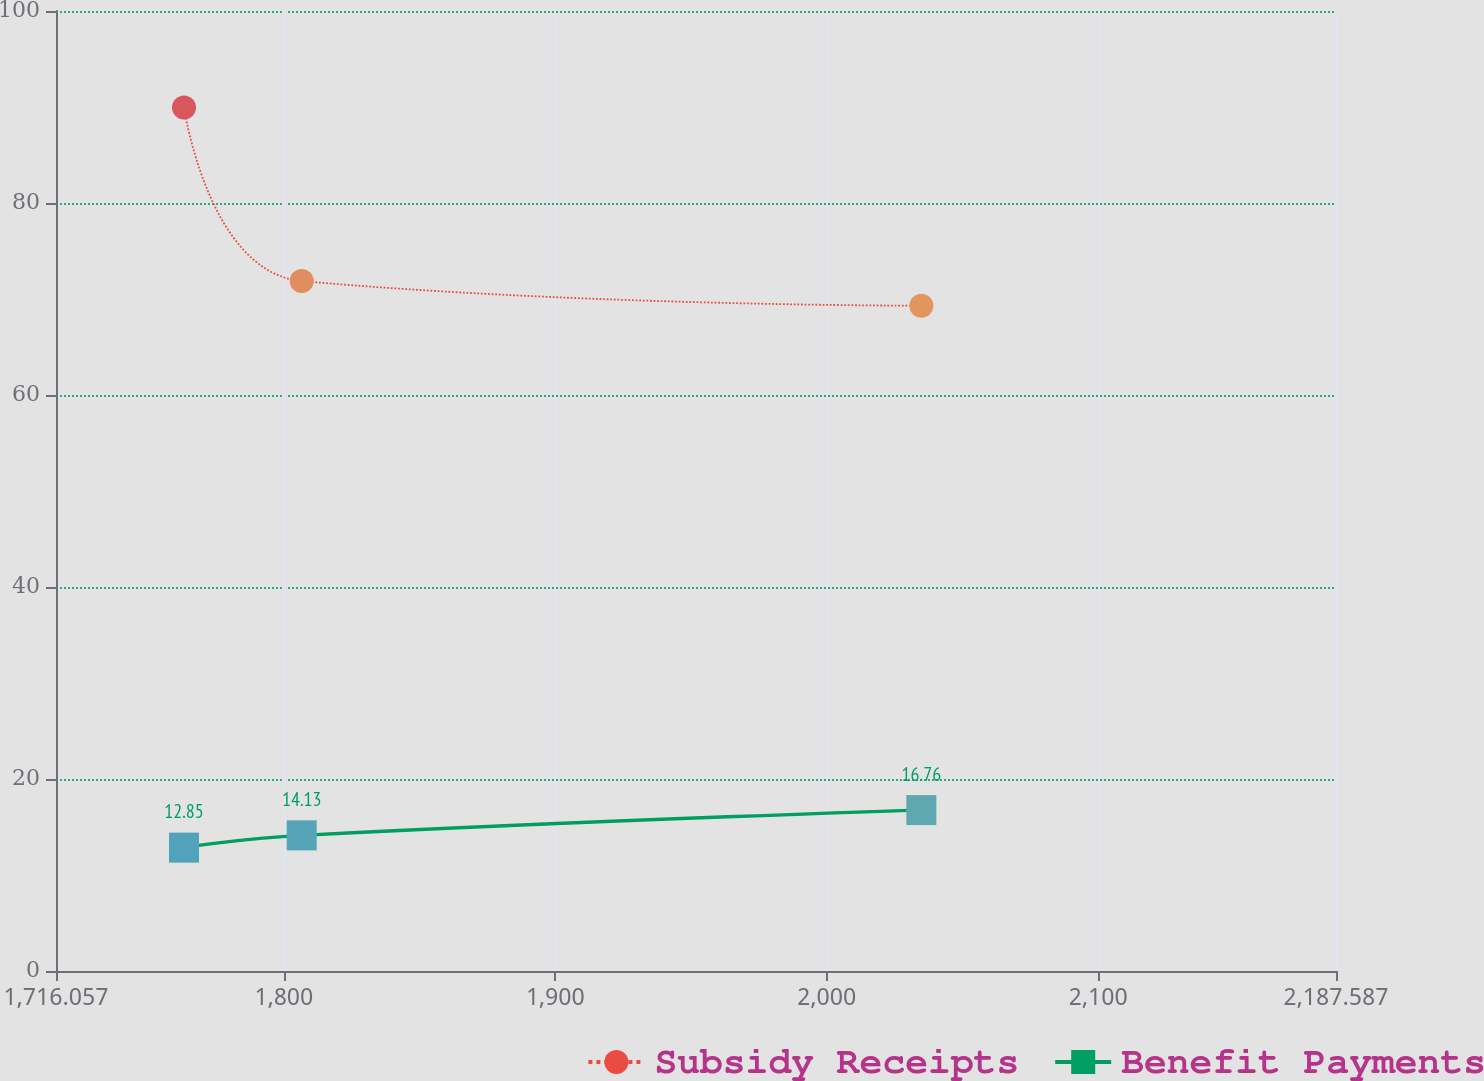Convert chart. <chart><loc_0><loc_0><loc_500><loc_500><line_chart><ecel><fcel>Subsidy Receipts<fcel>Benefit Payments<nl><fcel>1763.21<fcel>89.95<fcel>12.85<nl><fcel>1806.57<fcel>71.87<fcel>14.13<nl><fcel>2034.84<fcel>69.3<fcel>16.76<nl><fcel>2191.38<fcel>66.73<fcel>17.51<nl><fcel>2234.74<fcel>92.52<fcel>16.29<nl></chart> 